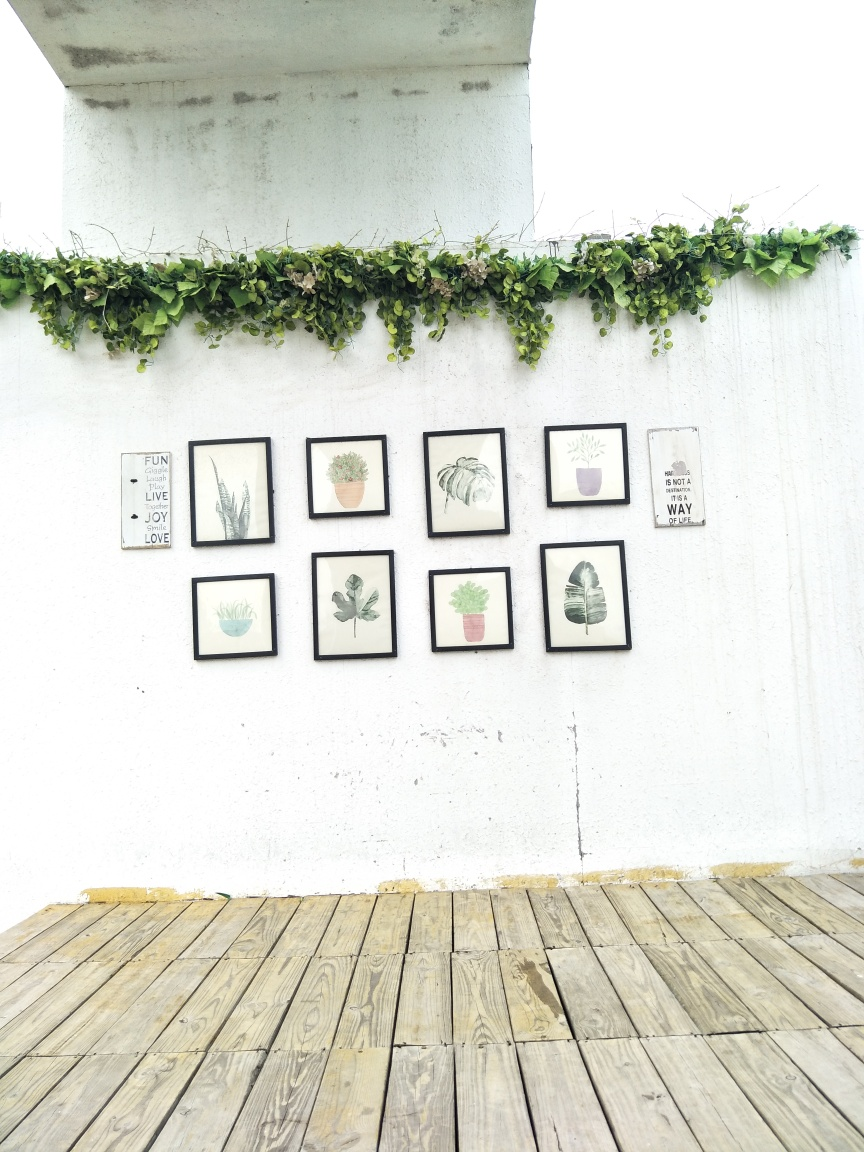Are the colors good?
A. No
B. Yes
Answer with the option's letter from the given choices directly. While the colors in the image are rather muted, consisting primarily of various shades of green from the hanging plants and the wood tones of the floor, the overall aesthetic is harmonious and pleasing. The framed plant illustrations on the wall add a touch of subtle color variation which complements the natural theme. The white wall serves as a neutral background that accentuates the frames and the foliage. So, considering the natural and understated color palette, we can appreciate the color choices, and my answer is B. Yes, the colors are good. 